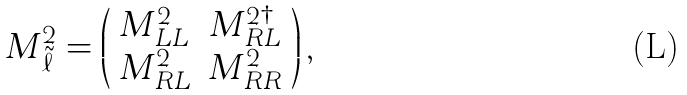Convert formula to latex. <formula><loc_0><loc_0><loc_500><loc_500>M ^ { 2 } _ { \tilde { \ell } } = \left ( \begin{array} { c c } M ^ { 2 } _ { L L } & M ^ { 2 \dagger } _ { R L } \\ M ^ { 2 } _ { R L } & M ^ { 2 } _ { R R } \\ \end{array} \right ) ,</formula> 